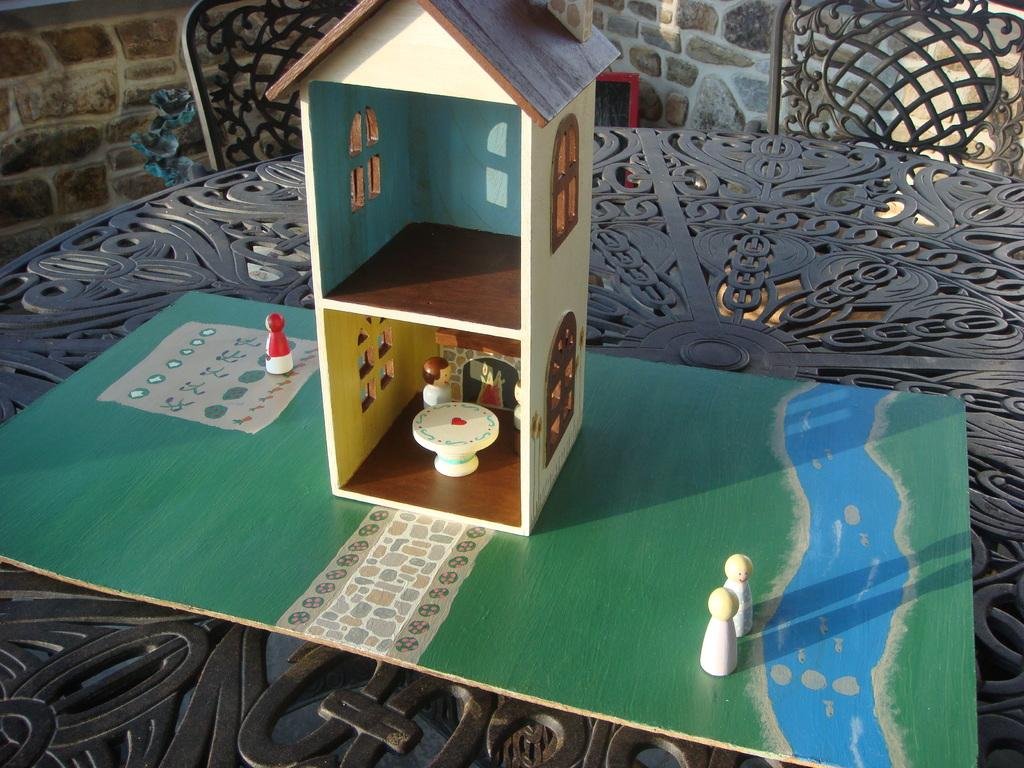What type of toy is on the table in the image? There is a toy house on the table in the image. What furniture can be seen in the image? There are chairs in the image. What can be seen in the background of the image? There is a wall visible in the background of the image. What type of ocean can be seen in the image? There is no ocean present in the image. 